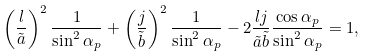<formula> <loc_0><loc_0><loc_500><loc_500>\left ( \frac { l } { \tilde { a } } \right ) ^ { 2 } \frac { 1 } { \sin ^ { 2 } \alpha _ { p } } + \left ( \frac { j } { \tilde { b } } \right ) ^ { 2 } \frac { 1 } { \sin ^ { 2 } \alpha _ { p } } - 2 \frac { l j } { \tilde { a } \tilde { b } } \frac { \cos \alpha _ { p } } { \sin ^ { 2 } \alpha _ { p } } = 1 ,</formula> 